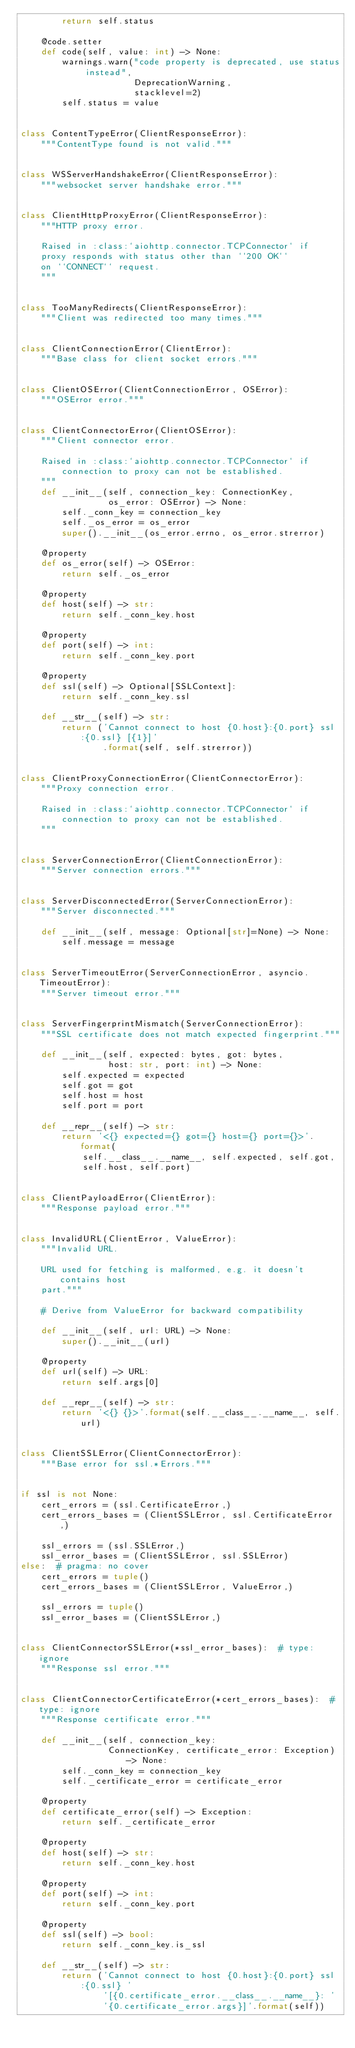Convert code to text. <code><loc_0><loc_0><loc_500><loc_500><_Python_>        return self.status

    @code.setter
    def code(self, value: int) -> None:
        warnings.warn("code property is deprecated, use status instead",
                      DeprecationWarning,
                      stacklevel=2)
        self.status = value


class ContentTypeError(ClientResponseError):
    """ContentType found is not valid."""


class WSServerHandshakeError(ClientResponseError):
    """websocket server handshake error."""


class ClientHttpProxyError(ClientResponseError):
    """HTTP proxy error.

    Raised in :class:`aiohttp.connector.TCPConnector` if
    proxy responds with status other than ``200 OK``
    on ``CONNECT`` request.
    """


class TooManyRedirects(ClientResponseError):
    """Client was redirected too many times."""


class ClientConnectionError(ClientError):
    """Base class for client socket errors."""


class ClientOSError(ClientConnectionError, OSError):
    """OSError error."""


class ClientConnectorError(ClientOSError):
    """Client connector error.

    Raised in :class:`aiohttp.connector.TCPConnector` if
        connection to proxy can not be established.
    """
    def __init__(self, connection_key: ConnectionKey,
                 os_error: OSError) -> None:
        self._conn_key = connection_key
        self._os_error = os_error
        super().__init__(os_error.errno, os_error.strerror)

    @property
    def os_error(self) -> OSError:
        return self._os_error

    @property
    def host(self) -> str:
        return self._conn_key.host

    @property
    def port(self) -> int:
        return self._conn_key.port

    @property
    def ssl(self) -> Optional[SSLContext]:
        return self._conn_key.ssl

    def __str__(self) -> str:
        return ('Cannot connect to host {0.host}:{0.port} ssl:{0.ssl} [{1}]'
                .format(self, self.strerror))


class ClientProxyConnectionError(ClientConnectorError):
    """Proxy connection error.

    Raised in :class:`aiohttp.connector.TCPConnector` if
        connection to proxy can not be established.
    """


class ServerConnectionError(ClientConnectionError):
    """Server connection errors."""


class ServerDisconnectedError(ServerConnectionError):
    """Server disconnected."""

    def __init__(self, message: Optional[str]=None) -> None:
        self.message = message


class ServerTimeoutError(ServerConnectionError, asyncio.TimeoutError):
    """Server timeout error."""


class ServerFingerprintMismatch(ServerConnectionError):
    """SSL certificate does not match expected fingerprint."""

    def __init__(self, expected: bytes, got: bytes,
                 host: str, port: int) -> None:
        self.expected = expected
        self.got = got
        self.host = host
        self.port = port

    def __repr__(self) -> str:
        return '<{} expected={} got={} host={} port={}>'.format(
            self.__class__.__name__, self.expected, self.got,
            self.host, self.port)


class ClientPayloadError(ClientError):
    """Response payload error."""


class InvalidURL(ClientError, ValueError):
    """Invalid URL.

    URL used for fetching is malformed, e.g. it doesn't contains host
    part."""

    # Derive from ValueError for backward compatibility

    def __init__(self, url: URL) -> None:
        super().__init__(url)

    @property
    def url(self) -> URL:
        return self.args[0]

    def __repr__(self) -> str:
        return '<{} {}>'.format(self.__class__.__name__, self.url)


class ClientSSLError(ClientConnectorError):
    """Base error for ssl.*Errors."""


if ssl is not None:
    cert_errors = (ssl.CertificateError,)
    cert_errors_bases = (ClientSSLError, ssl.CertificateError,)

    ssl_errors = (ssl.SSLError,)
    ssl_error_bases = (ClientSSLError, ssl.SSLError)
else:  # pragma: no cover
    cert_errors = tuple()
    cert_errors_bases = (ClientSSLError, ValueError,)

    ssl_errors = tuple()
    ssl_error_bases = (ClientSSLError,)


class ClientConnectorSSLError(*ssl_error_bases):  # type: ignore
    """Response ssl error."""


class ClientConnectorCertificateError(*cert_errors_bases):  # type: ignore
    """Response certificate error."""

    def __init__(self, connection_key:
                 ConnectionKey, certificate_error: Exception) -> None:
        self._conn_key = connection_key
        self._certificate_error = certificate_error

    @property
    def certificate_error(self) -> Exception:
        return self._certificate_error

    @property
    def host(self) -> str:
        return self._conn_key.host

    @property
    def port(self) -> int:
        return self._conn_key.port

    @property
    def ssl(self) -> bool:
        return self._conn_key.is_ssl

    def __str__(self) -> str:
        return ('Cannot connect to host {0.host}:{0.port} ssl:{0.ssl} '
                '[{0.certificate_error.__class__.__name__}: '
                '{0.certificate_error.args}]'.format(self))
</code> 